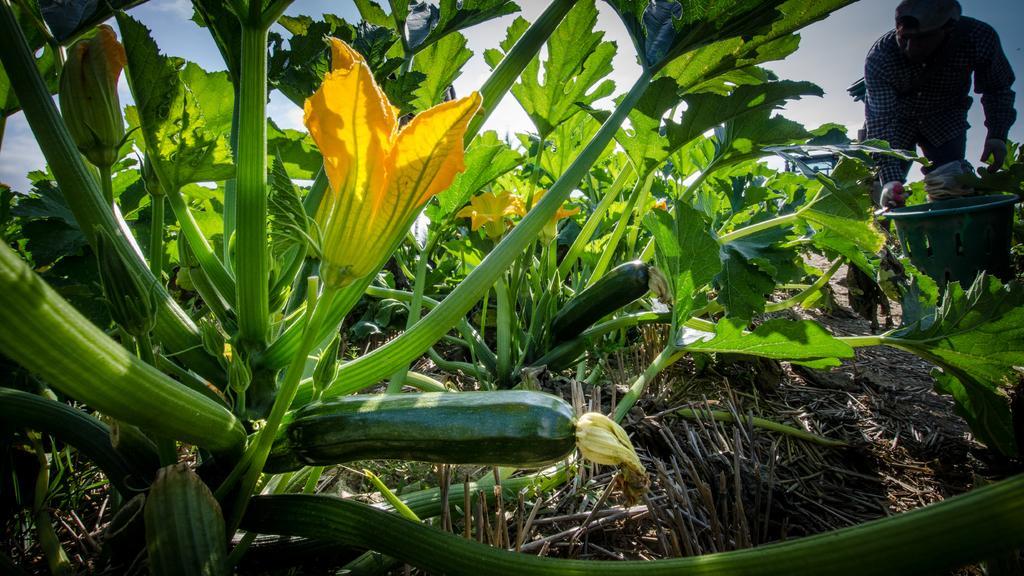Can you describe this image briefly? In this picture, we see the plants which have yellow flowers and cucumbers. At the bottom of the picture, we see the twigs. On the right side, the man in the check shirt is holding the green tube in his hand and he is collecting the cucumbers. In the background, we see the sky. 